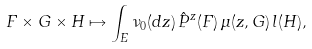Convert formula to latex. <formula><loc_0><loc_0><loc_500><loc_500>F \times G \times H \mapsto \int _ { E } \nu _ { 0 } ( d z ) \, \hat { P } ^ { z } ( F ) \, \mu ( z , G ) \, l ( H ) ,</formula> 